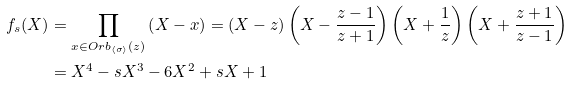<formula> <loc_0><loc_0><loc_500><loc_500>f _ { s } ( X ) & = \prod _ { x \in O r b _ { \langle \sigma \rangle } ( z ) } \left ( X - x \right ) = \left ( X - z \right ) \left ( X - \frac { z - 1 } { z + 1 } \right ) \left ( X + \frac { 1 } { z } \right ) \left ( X + \frac { z + 1 } { z - 1 } \right ) \\ & = X ^ { 4 } - s X ^ { 3 } - 6 X ^ { 2 } + s X + 1</formula> 